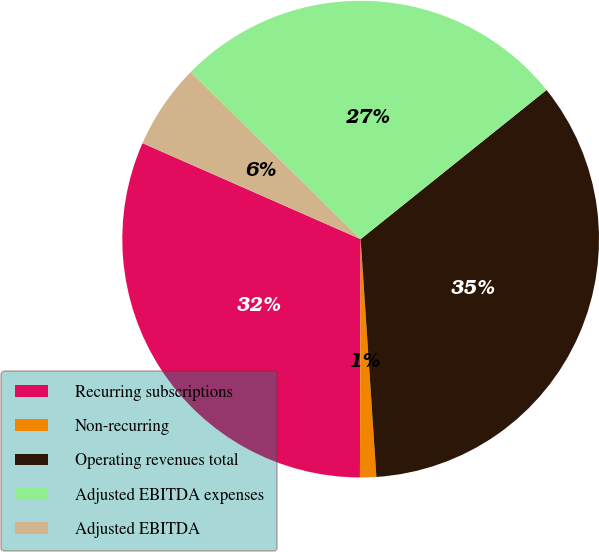Convert chart. <chart><loc_0><loc_0><loc_500><loc_500><pie_chart><fcel>Recurring subscriptions<fcel>Non-recurring<fcel>Operating revenues total<fcel>Adjusted EBITDA expenses<fcel>Adjusted EBITDA<nl><fcel>31.55%<fcel>1.1%<fcel>34.71%<fcel>26.88%<fcel>5.76%<nl></chart> 